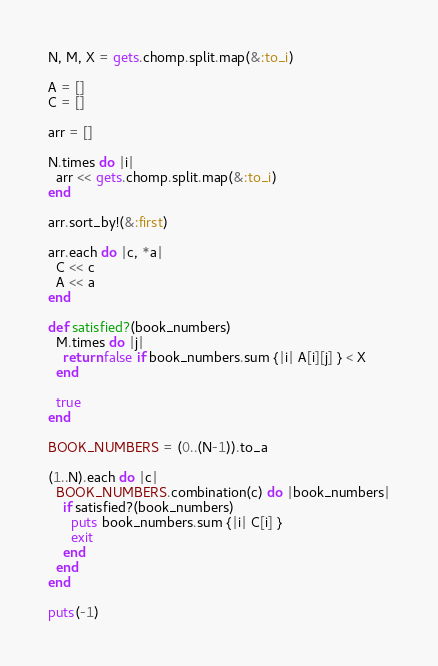<code> <loc_0><loc_0><loc_500><loc_500><_Ruby_>N, M, X = gets.chomp.split.map(&:to_i)

A = []
C = []

arr = []

N.times do |i|
  arr << gets.chomp.split.map(&:to_i)
end

arr.sort_by!(&:first)

arr.each do |c, *a|
  C << c
  A << a
end

def satisfied?(book_numbers)
  M.times do |j|
    return false if book_numbers.sum {|i| A[i][j] } < X
  end

  true
end

BOOK_NUMBERS = (0..(N-1)).to_a

(1..N).each do |c|
  BOOK_NUMBERS.combination(c) do |book_numbers|
    if satisfied?(book_numbers)
      puts book_numbers.sum {|i| C[i] }
      exit
    end
  end
end

puts(-1)
</code> 